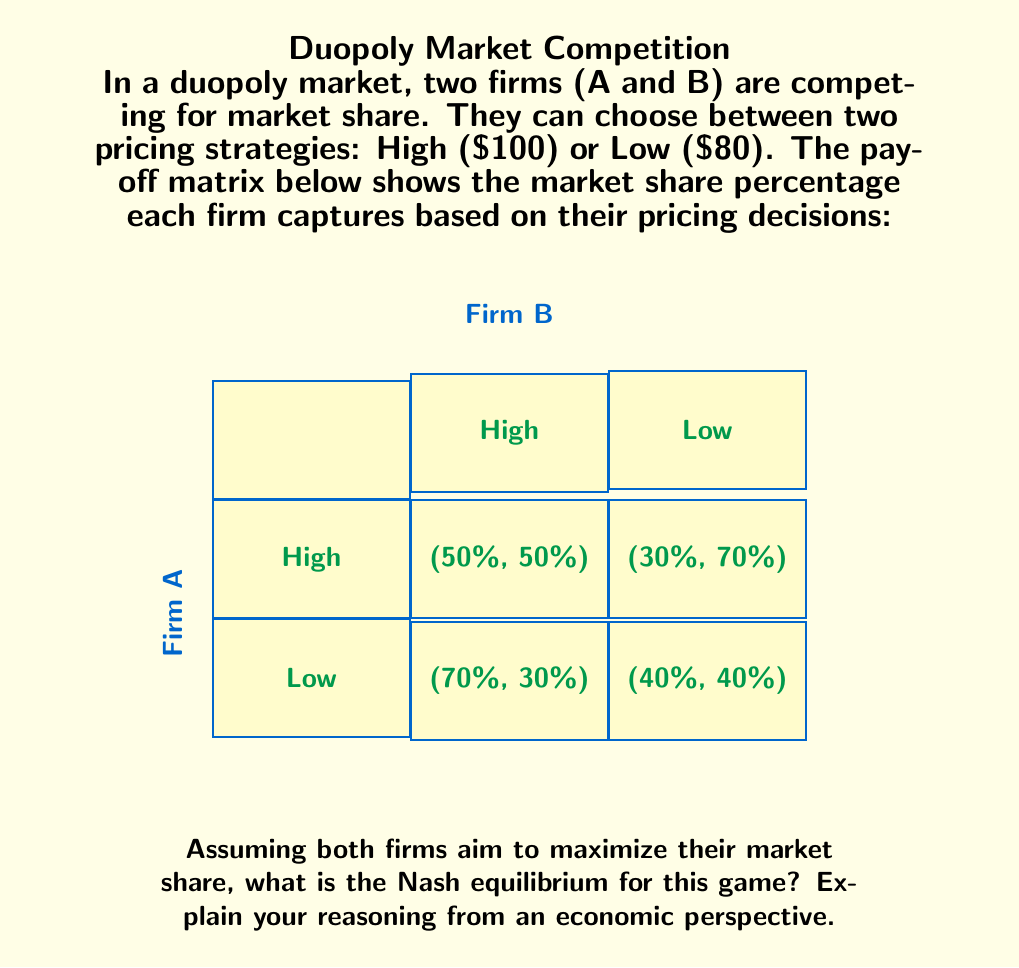Solve this math problem. To find the Nash equilibrium, we need to analyze each firm's best response to the other firm's strategy. Let's approach this step-by-step:

1) First, let's consider Firm A's perspective:
   - If Firm B chooses High:
     Firm A choosing High gives 50% market share
     Firm A choosing Low gives 70% market share
   - If Firm B chooses Low:
     Firm A choosing High gives 30% market share
     Firm A choosing Low gives 40% market share

   Firm A's best response is always to choose Low, regardless of Firm B's choice.

2) Now, let's consider Firm B's perspective:
   - If Firm A chooses High:
     Firm B choosing High gives 50% market share
     Firm B choosing Low gives 70% market share
   - If Firm A chooses Low:
     Firm B choosing High gives 30% market share
     Firm B choosing Low gives 40% market share

   Firm B's best response is also always to choose Low, regardless of Firm A's choice.

3) The Nash equilibrium occurs when both firms are playing their best responses to each other's strategies. In this case, that happens when both firms choose Low pricing.

4) From an economic perspective, this result demonstrates the concept of price competition in a duopoly. Both firms have an incentive to undercut their competitor's price to gain market share. This leads to a "race to the bottom" where both firms end up choosing the lower price strategy.

5) This outcome, while individually rational for each firm, may not be the most profitable for either firm. If they could cooperate and both choose High pricing, they would each get a 50% market share at a higher price point, potentially leading to higher profits. However, the incentive to deviate from this agreement makes it unstable without external enforcement mechanisms.

6) This game illustrates why purely competitive markets often lead to lower prices for consumers, but also highlights the potential inefficiencies that can arise when firms are unable to coordinate their actions for mutual benefit.
Answer: Nash equilibrium: (Low, Low) 